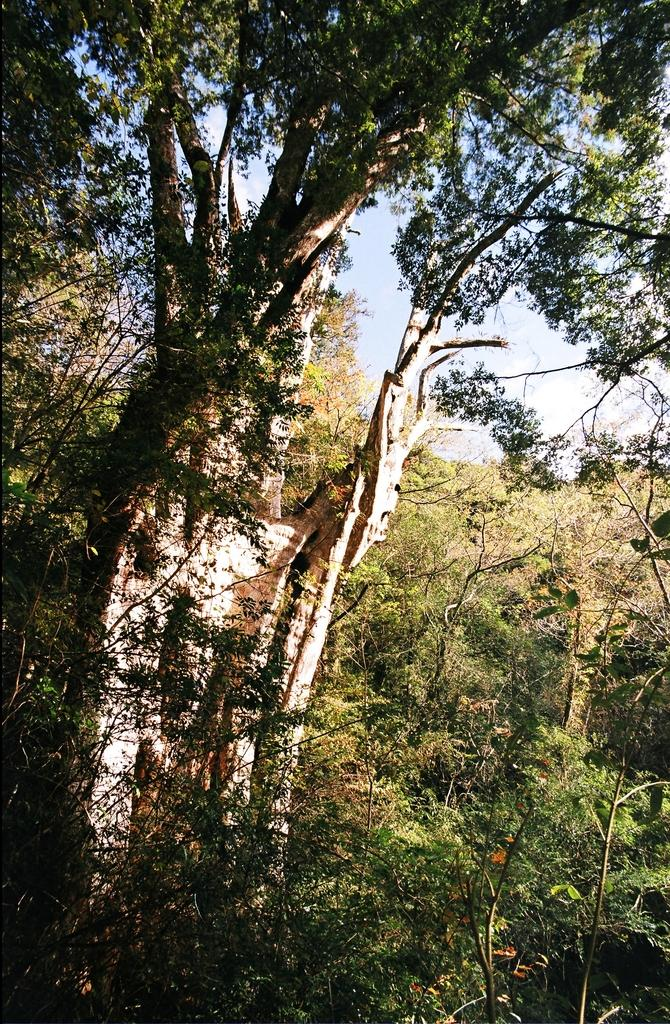What type of environment is depicted in the image? The image features greenery, suggesting a natural or outdoor setting. What type of tray is being used to serve the quince in the image? There is no tray or quince present in the image; it only features greenery. 